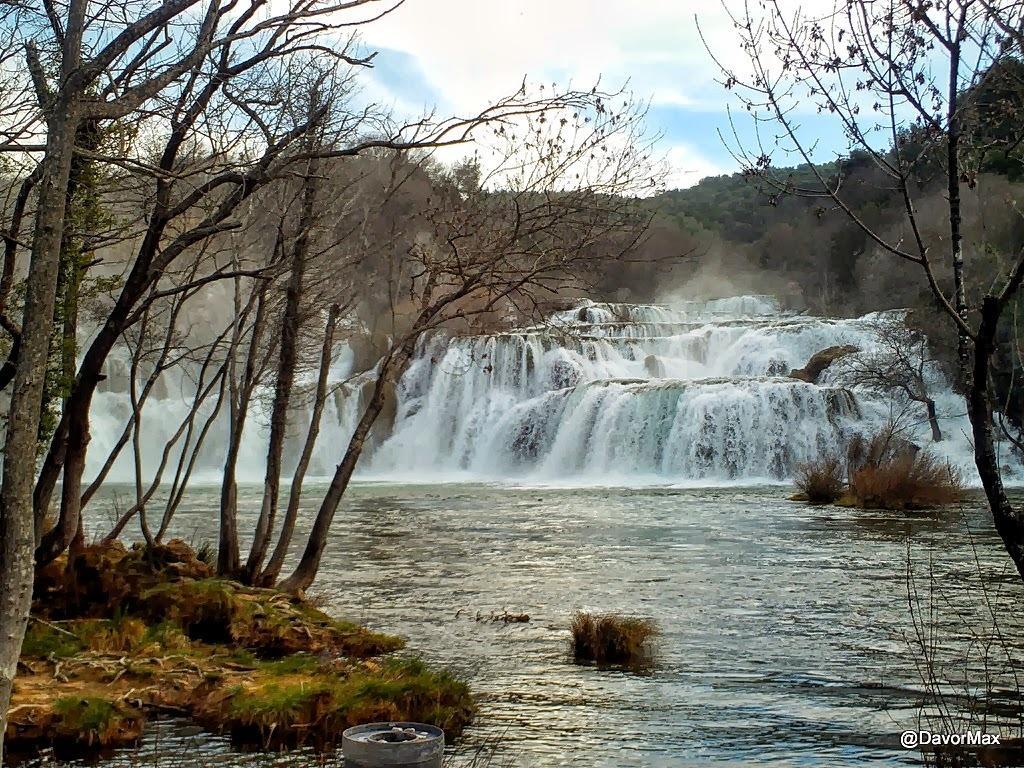Can you describe this image briefly? This is an outside view. At the bottom, I can see the water. On the right and left side of the image I can see the trees. In the middle of the image I can see the waterfalls. In the background there are many trees and a hill. At the top of the image I can see the sky and clouds. 